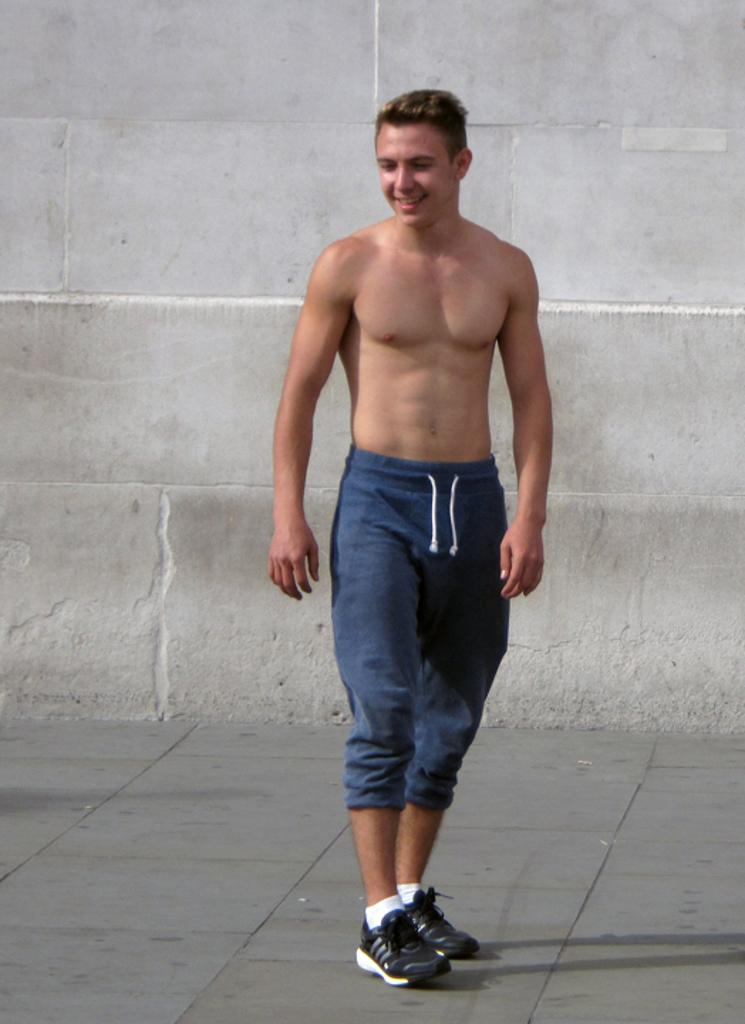What is the main subject of the image? There is a person standing in the center of the image. What can be seen in the background of the image? There is a wall in the background of the image. What is the surface on which the person is standing? There is a floor at the bottom of the image. How much debt is the person carrying in the image? There is no information about the person's debt in the image. Where is the shelf located in the image? There is no shelf present in the image. 